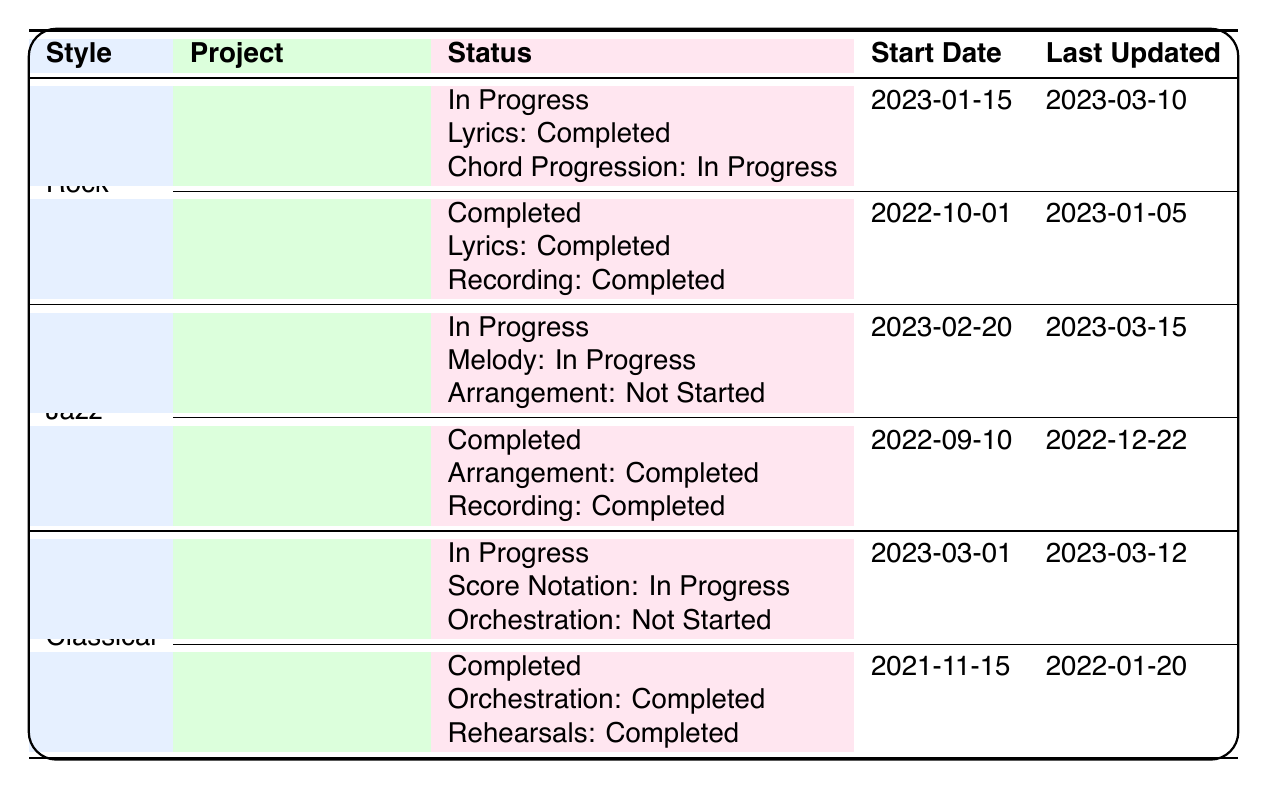What is the status of the project "Electric Dreams"? The table shows that "Electric Dreams" is marked as "In Progress" under the 'Rock' style category.
Answer: In Progress How many projects are listed under the Jazz category? The table indicates that there are two projects listed under the Jazz category: "Smooth As Silk" and "Late Night Groove."
Answer: 2 Is the "Recording" milestone for "Smooth As Silk" started? According to the table, the "Recording" milestone for "Smooth As Silk" is marked as "Not Started."
Answer: No Which project under the Classical category has the most recent start date? The project "Sonata in D Minor" has the most recent start date of "2023-03-01," compared to "Nocturne in E-flat," which started on "2021-11-15."
Answer: Sonata in D Minor What percentage of the milestones in "Midnight Soliloquy" are completed? "Midnight Soliloquy" has three milestones. Two are completed (Lyrics and Chord Progression), while one is completed (Recording). Therefore, (2/3) * 100 = 66.67%.
Answer: 66.67% How many milestones are still pending for the project "Sonata in D Minor"? The project "Sonata in D Minor" has three milestones, where "Score Notation" is "In Progress," and "Orchestration" and "Rehearsals" are "Not Started." Therefore, two milestones are pending.
Answer: 2 Which style has the project with the latest last updated date? Checking the last updated dates, "Smooth As Silk" under Jazz was updated last on "2023-03-15," which is the latest date compared to the others.
Answer: Jazz What is the completion status of the "Late Night Groove" project? From the table, it is clear that "Late Night Groove" is marked as "Completed."
Answer: Completed How many projects have completion statuses that are 'In Progress'? There are three projects with the status 'In Progress': "Electric Dreams," "Smooth As Silk," and "Sonata in D Minor." Therefore, the count is three.
Answer: 3 